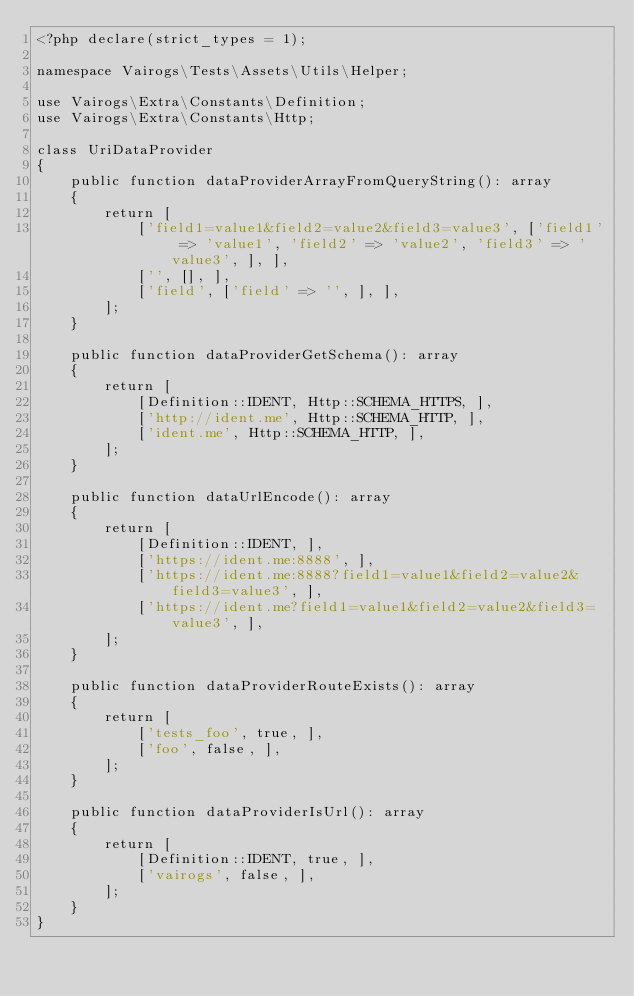<code> <loc_0><loc_0><loc_500><loc_500><_PHP_><?php declare(strict_types = 1);

namespace Vairogs\Tests\Assets\Utils\Helper;

use Vairogs\Extra\Constants\Definition;
use Vairogs\Extra\Constants\Http;

class UriDataProvider
{
    public function dataProviderArrayFromQueryString(): array
    {
        return [
            ['field1=value1&field2=value2&field3=value3', ['field1' => 'value1', 'field2' => 'value2', 'field3' => 'value3', ], ],
            ['', [], ],
            ['field', ['field' => '', ], ],
        ];
    }

    public function dataProviderGetSchema(): array
    {
        return [
            [Definition::IDENT, Http::SCHEMA_HTTPS, ],
            ['http://ident.me', Http::SCHEMA_HTTP, ],
            ['ident.me', Http::SCHEMA_HTTP, ],
        ];
    }

    public function dataUrlEncode(): array
    {
        return [
            [Definition::IDENT, ],
            ['https://ident.me:8888', ],
            ['https://ident.me:8888?field1=value1&field2=value2&field3=value3', ],
            ['https://ident.me?field1=value1&field2=value2&field3=value3', ],
        ];
    }

    public function dataProviderRouteExists(): array
    {
        return [
            ['tests_foo', true, ],
            ['foo', false, ],
        ];
    }

    public function dataProviderIsUrl(): array
    {
        return [
            [Definition::IDENT, true, ],
            ['vairogs', false, ],
        ];
    }
}
</code> 